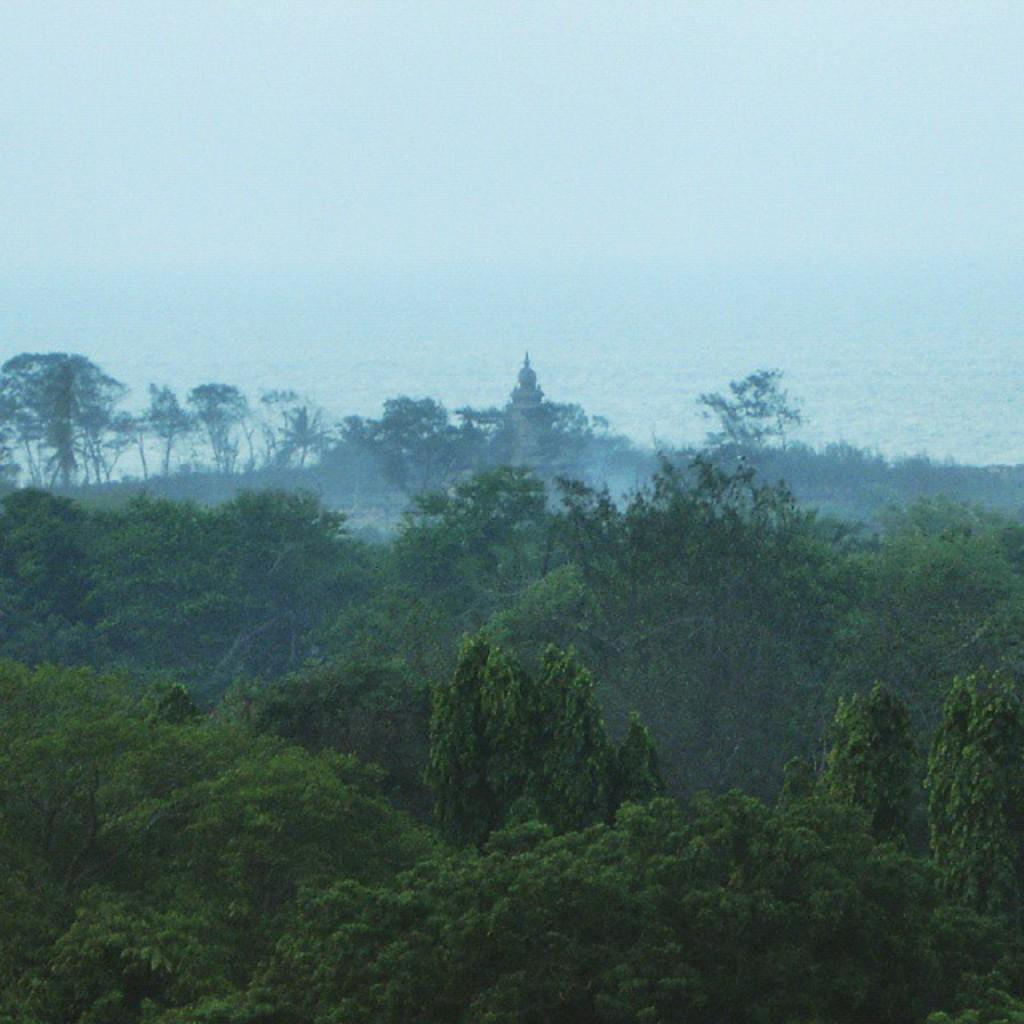What type of vegetation is present at the bottom of the image? There are trees at the bottom of the image. What part of the natural environment is visible at the top of the image? The sky is visible at the top of the image. What type of advertisement can be seen on the trees in the image? There are no advertisements present on the trees in the image; only trees are visible. How many women are interacting with the trees in the image? There are no women present in the image; only trees are visible. 